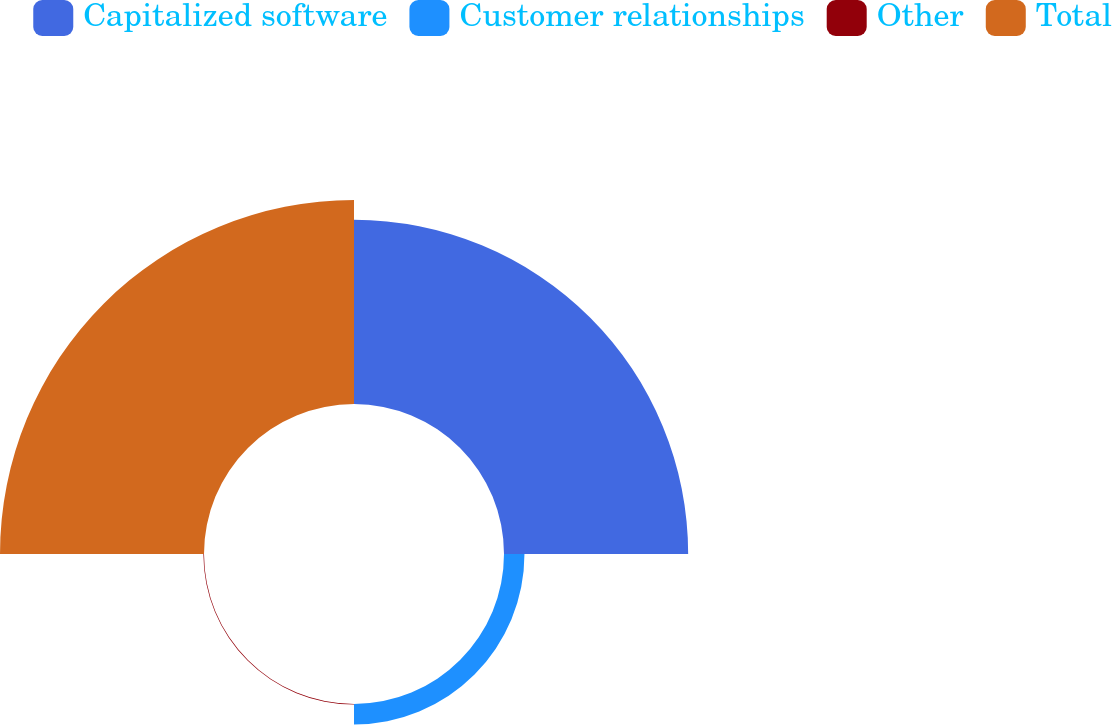Convert chart to OTSL. <chart><loc_0><loc_0><loc_500><loc_500><pie_chart><fcel>Capitalized software<fcel>Customer relationships<fcel>Other<fcel>Total<nl><fcel>45.0%<fcel>5.0%<fcel>0.15%<fcel>49.85%<nl></chart> 